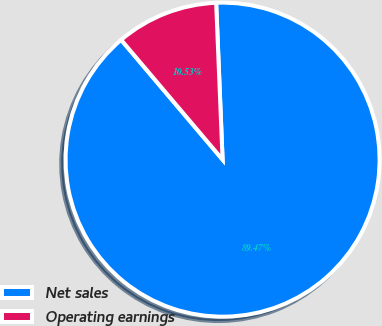Convert chart. <chart><loc_0><loc_0><loc_500><loc_500><pie_chart><fcel>Net sales<fcel>Operating earnings<nl><fcel>89.47%<fcel>10.53%<nl></chart> 